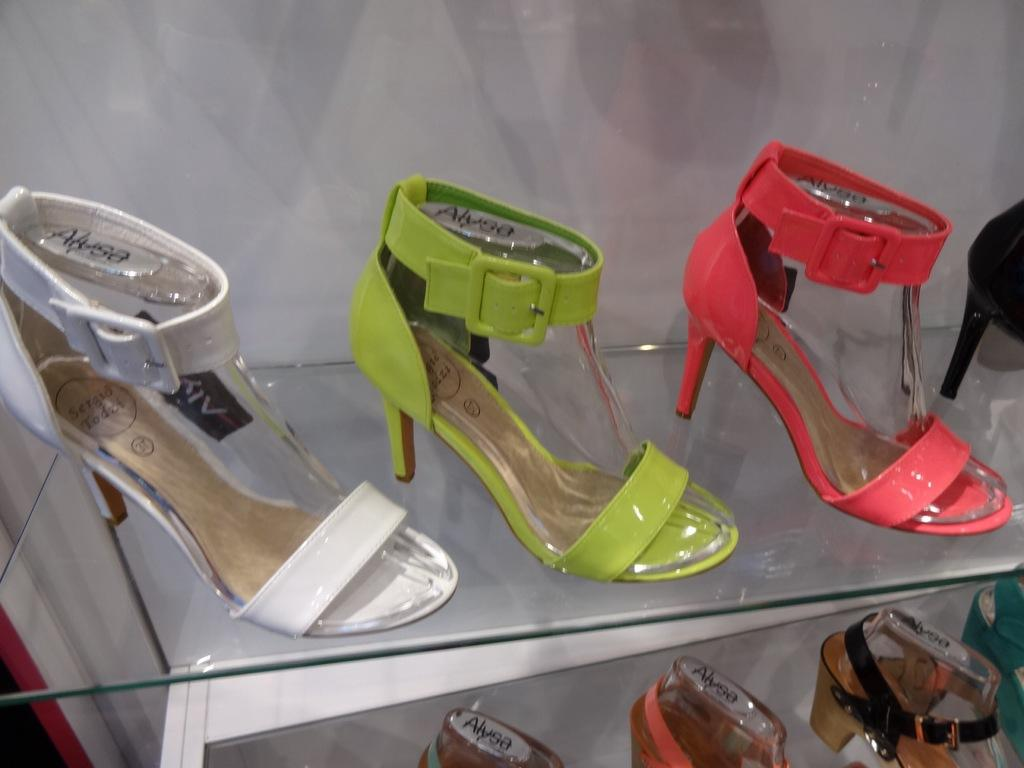<image>
Share a concise interpretation of the image provided. A glass shelf has lots of high heels and they all say Alysa. 